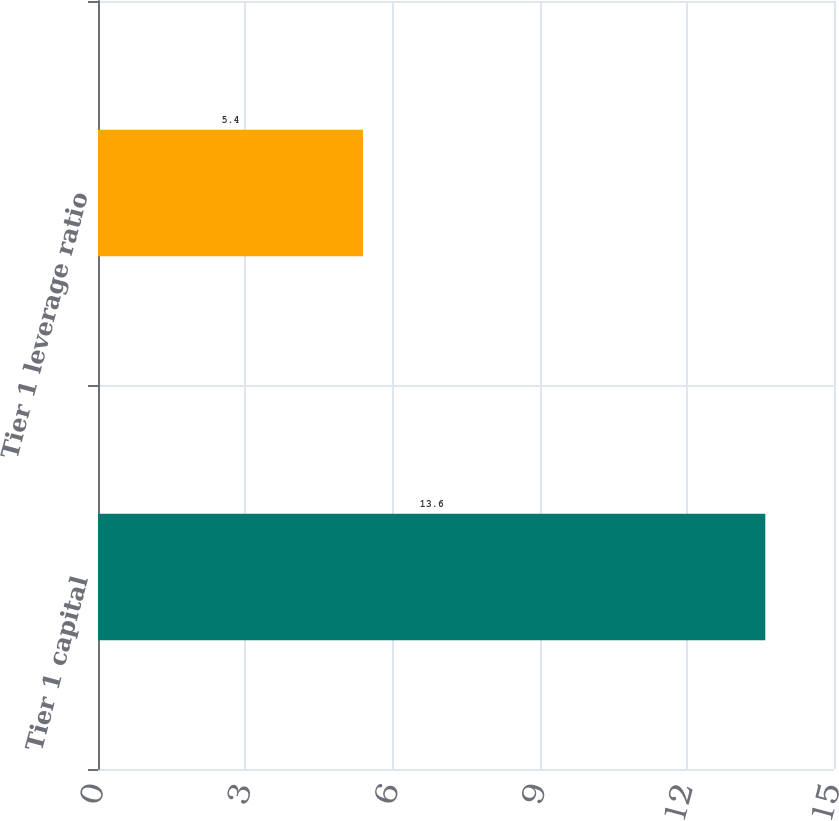Convert chart to OTSL. <chart><loc_0><loc_0><loc_500><loc_500><bar_chart><fcel>Tier 1 capital<fcel>Tier 1 leverage ratio<nl><fcel>13.6<fcel>5.4<nl></chart> 